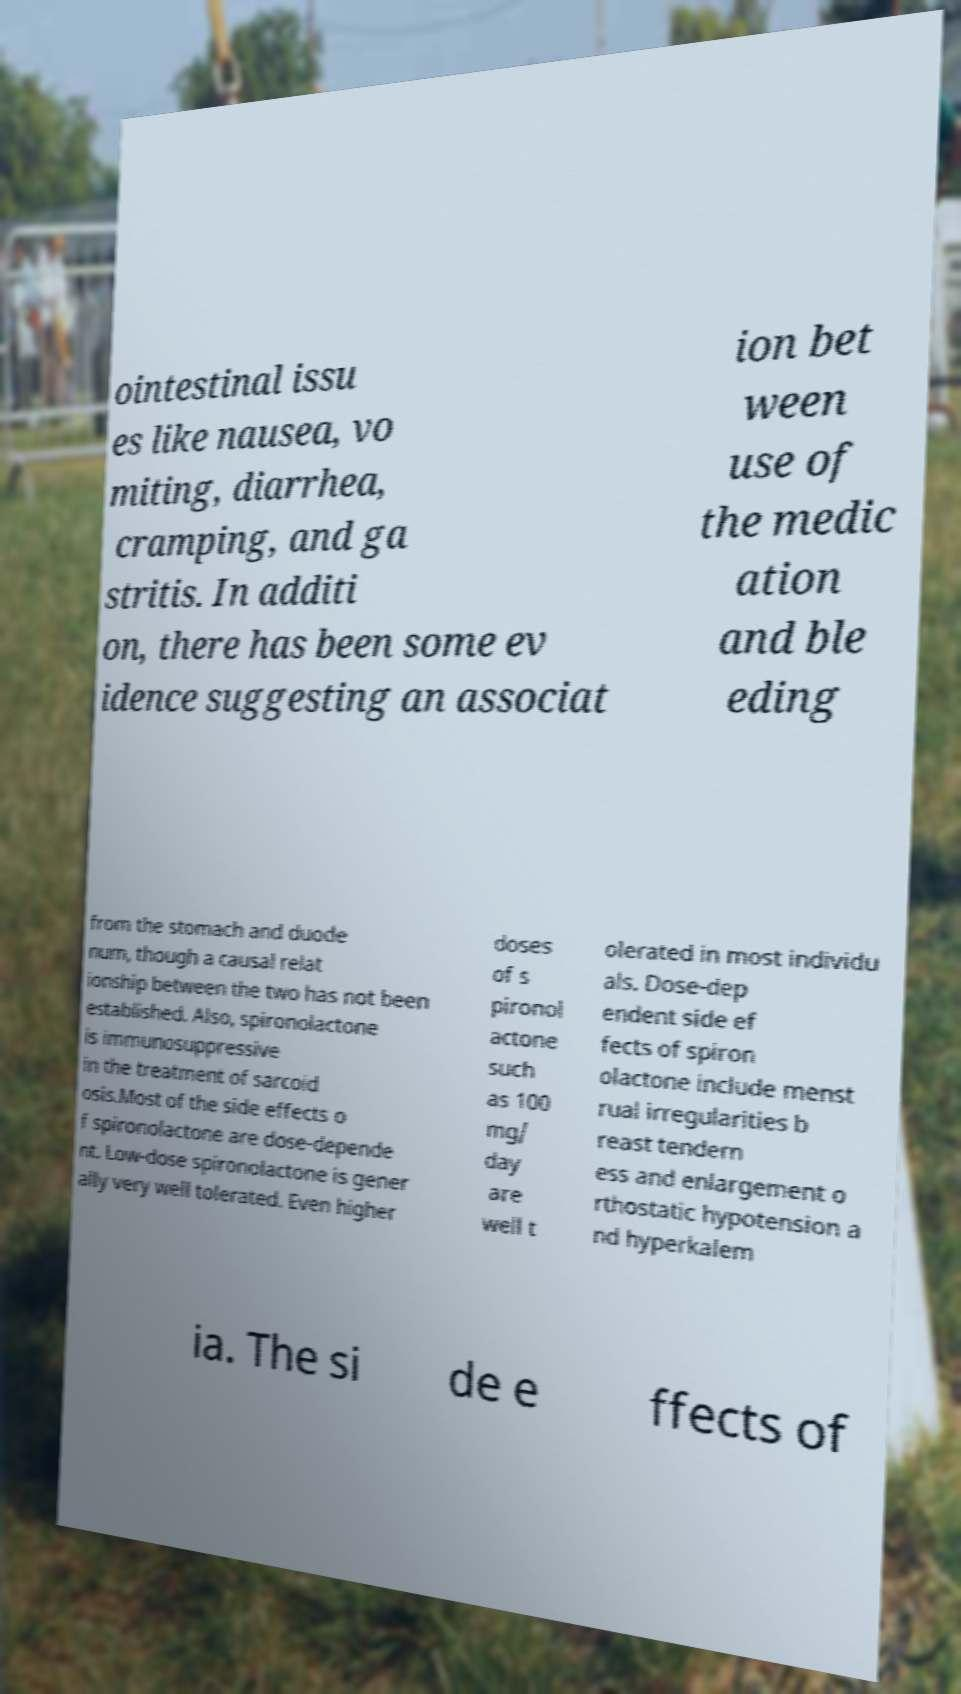Please identify and transcribe the text found in this image. ointestinal issu es like nausea, vo miting, diarrhea, cramping, and ga stritis. In additi on, there has been some ev idence suggesting an associat ion bet ween use of the medic ation and ble eding from the stomach and duode num, though a causal relat ionship between the two has not been established. Also, spironolactone is immunosuppressive in the treatment of sarcoid osis.Most of the side effects o f spironolactone are dose-depende nt. Low-dose spironolactone is gener ally very well tolerated. Even higher doses of s pironol actone such as 100 mg/ day are well t olerated in most individu als. Dose-dep endent side ef fects of spiron olactone include menst rual irregularities b reast tendern ess and enlargement o rthostatic hypotension a nd hyperkalem ia. The si de e ffects of 